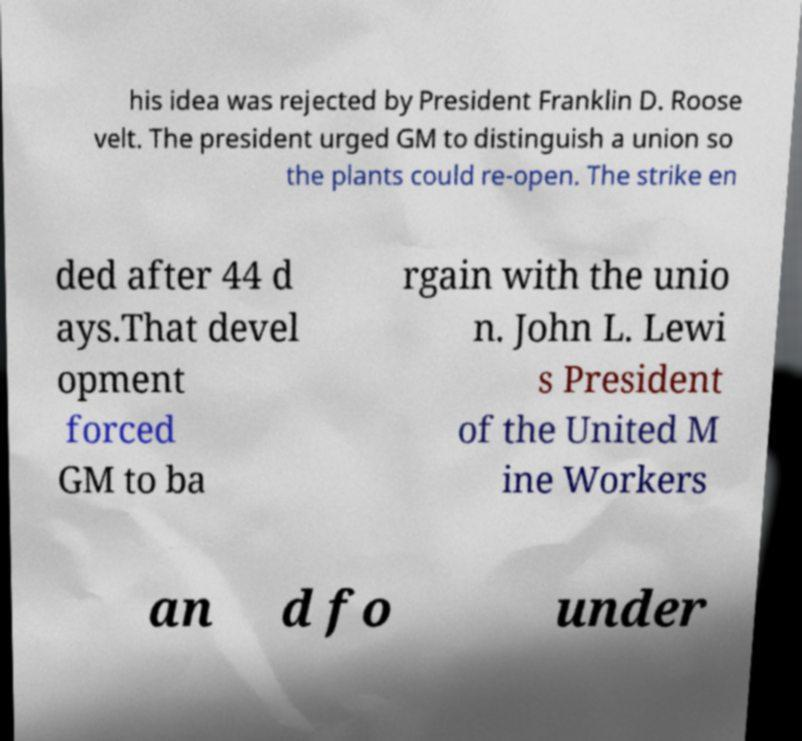There's text embedded in this image that I need extracted. Can you transcribe it verbatim? his idea was rejected by President Franklin D. Roose velt. The president urged GM to distinguish a union so the plants could re-open. The strike en ded after 44 d ays.That devel opment forced GM to ba rgain with the unio n. John L. Lewi s President of the United M ine Workers an d fo under 